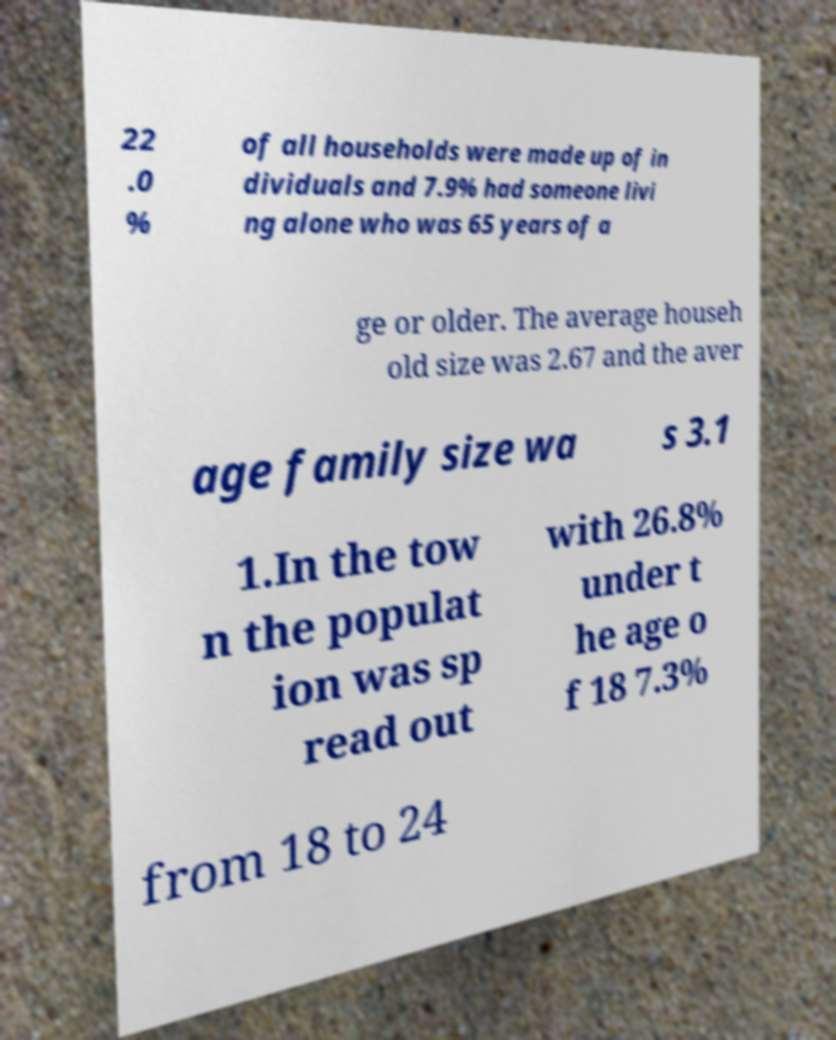Could you extract and type out the text from this image? 22 .0 % of all households were made up of in dividuals and 7.9% had someone livi ng alone who was 65 years of a ge or older. The average househ old size was 2.67 and the aver age family size wa s 3.1 1.In the tow n the populat ion was sp read out with 26.8% under t he age o f 18 7.3% from 18 to 24 